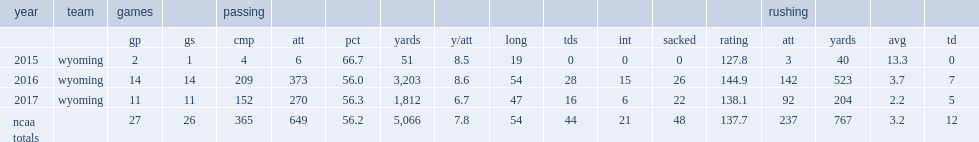How many passing yards did josh allen get in 2017? 1812.0. 